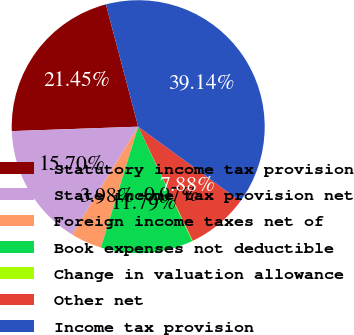<chart> <loc_0><loc_0><loc_500><loc_500><pie_chart><fcel>Statutory income tax provision<fcel>State income tax provision net<fcel>Foreign income taxes net of<fcel>Book expenses not deductible<fcel>Change in valuation allowance<fcel>Other net<fcel>Income tax provision<nl><fcel>21.45%<fcel>15.7%<fcel>3.98%<fcel>11.79%<fcel>0.07%<fcel>7.88%<fcel>39.14%<nl></chart> 